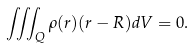<formula> <loc_0><loc_0><loc_500><loc_500>\iiint _ { Q } \rho ( r ) ( r - R ) d V = 0 .</formula> 